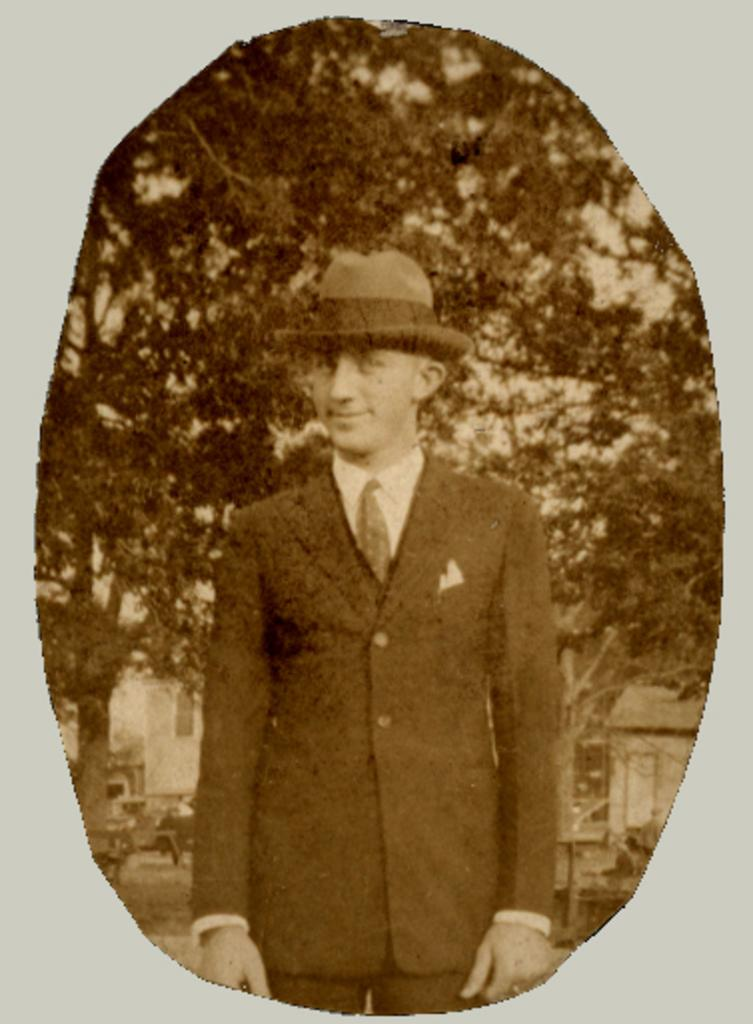What is the main subject of the image? There is a person in the image. What type of clothing is the person wearing? The person is wearing a blazer, a shirt, a tie, and a hat. What can be seen in the background of the image? There are trees and a house in the background of the image. What is the color scheme of the image? The image is black and white. How many pizzas are being served on the bed in the image? There are no pizzas or beds present in the image. Can you see any steam coming from the person's clothing in the image? There is no steam visible in the image. 